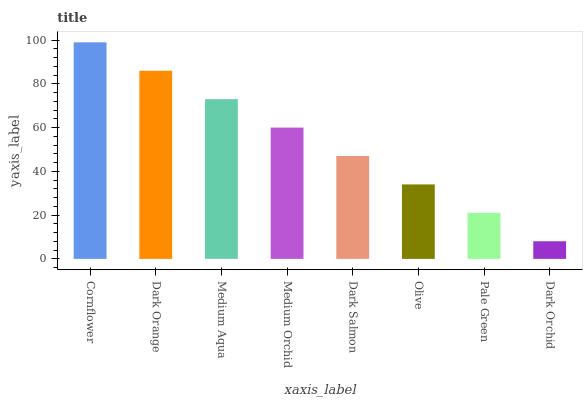Is Dark Orchid the minimum?
Answer yes or no. Yes. Is Cornflower the maximum?
Answer yes or no. Yes. Is Dark Orange the minimum?
Answer yes or no. No. Is Dark Orange the maximum?
Answer yes or no. No. Is Cornflower greater than Dark Orange?
Answer yes or no. Yes. Is Dark Orange less than Cornflower?
Answer yes or no. Yes. Is Dark Orange greater than Cornflower?
Answer yes or no. No. Is Cornflower less than Dark Orange?
Answer yes or no. No. Is Medium Orchid the high median?
Answer yes or no. Yes. Is Dark Salmon the low median?
Answer yes or no. Yes. Is Dark Salmon the high median?
Answer yes or no. No. Is Dark Orange the low median?
Answer yes or no. No. 